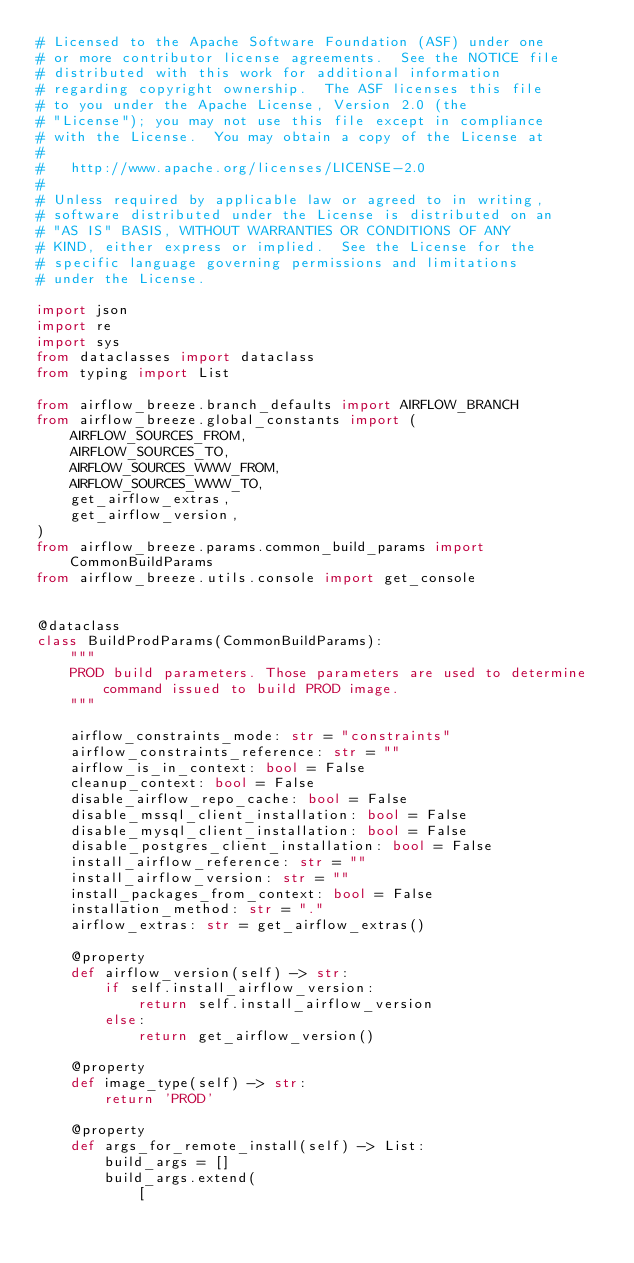<code> <loc_0><loc_0><loc_500><loc_500><_Python_># Licensed to the Apache Software Foundation (ASF) under one
# or more contributor license agreements.  See the NOTICE file
# distributed with this work for additional information
# regarding copyright ownership.  The ASF licenses this file
# to you under the Apache License, Version 2.0 (the
# "License"); you may not use this file except in compliance
# with the License.  You may obtain a copy of the License at
#
#   http://www.apache.org/licenses/LICENSE-2.0
#
# Unless required by applicable law or agreed to in writing,
# software distributed under the License is distributed on an
# "AS IS" BASIS, WITHOUT WARRANTIES OR CONDITIONS OF ANY
# KIND, either express or implied.  See the License for the
# specific language governing permissions and limitations
# under the License.

import json
import re
import sys
from dataclasses import dataclass
from typing import List

from airflow_breeze.branch_defaults import AIRFLOW_BRANCH
from airflow_breeze.global_constants import (
    AIRFLOW_SOURCES_FROM,
    AIRFLOW_SOURCES_TO,
    AIRFLOW_SOURCES_WWW_FROM,
    AIRFLOW_SOURCES_WWW_TO,
    get_airflow_extras,
    get_airflow_version,
)
from airflow_breeze.params.common_build_params import CommonBuildParams
from airflow_breeze.utils.console import get_console


@dataclass
class BuildProdParams(CommonBuildParams):
    """
    PROD build parameters. Those parameters are used to determine command issued to build PROD image.
    """

    airflow_constraints_mode: str = "constraints"
    airflow_constraints_reference: str = ""
    airflow_is_in_context: bool = False
    cleanup_context: bool = False
    disable_airflow_repo_cache: bool = False
    disable_mssql_client_installation: bool = False
    disable_mysql_client_installation: bool = False
    disable_postgres_client_installation: bool = False
    install_airflow_reference: str = ""
    install_airflow_version: str = ""
    install_packages_from_context: bool = False
    installation_method: str = "."
    airflow_extras: str = get_airflow_extras()

    @property
    def airflow_version(self) -> str:
        if self.install_airflow_version:
            return self.install_airflow_version
        else:
            return get_airflow_version()

    @property
    def image_type(self) -> str:
        return 'PROD'

    @property
    def args_for_remote_install(self) -> List:
        build_args = []
        build_args.extend(
            [</code> 